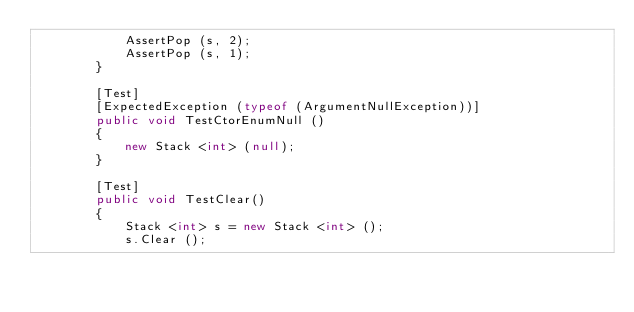Convert code to text. <code><loc_0><loc_0><loc_500><loc_500><_C#_>			AssertPop (s, 2);
			AssertPop (s, 1);
		}
		
		[Test]
		[ExpectedException (typeof (ArgumentNullException))]
		public void TestCtorEnumNull ()
		{
			new Stack <int> (null);
		}
		
		[Test]
		public void TestClear()
		{
			Stack <int> s = new Stack <int> ();
			s.Clear ();
			</code> 